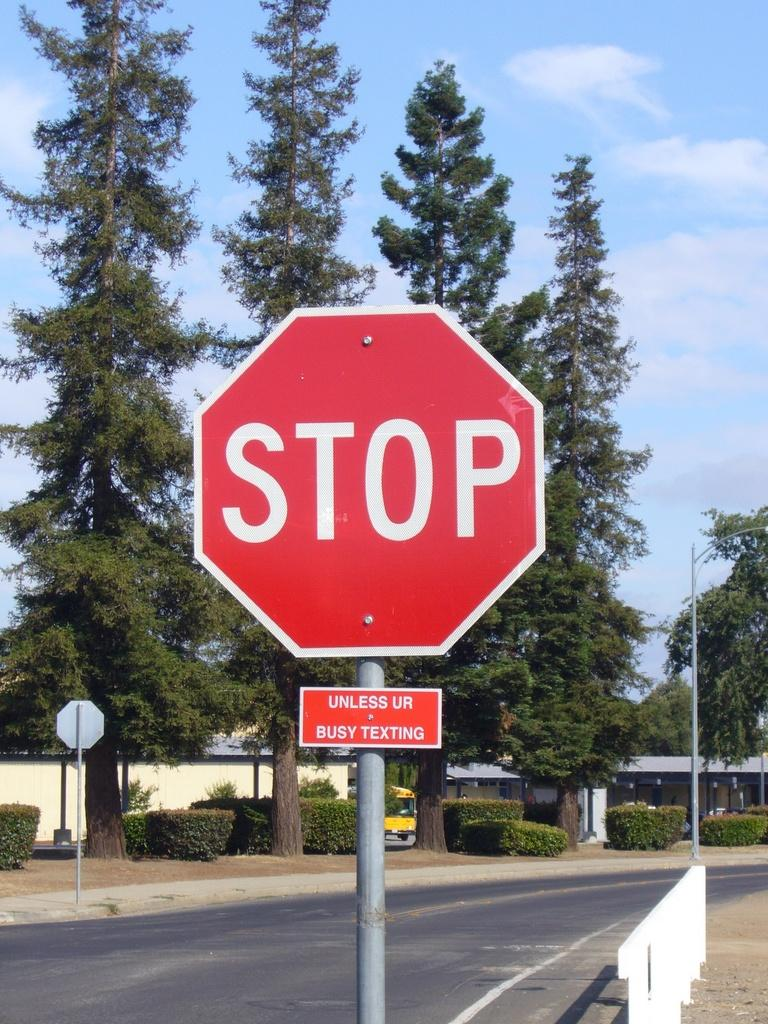Provide a one-sentence caption for the provided image. a stop sign that is near a group of trees. 